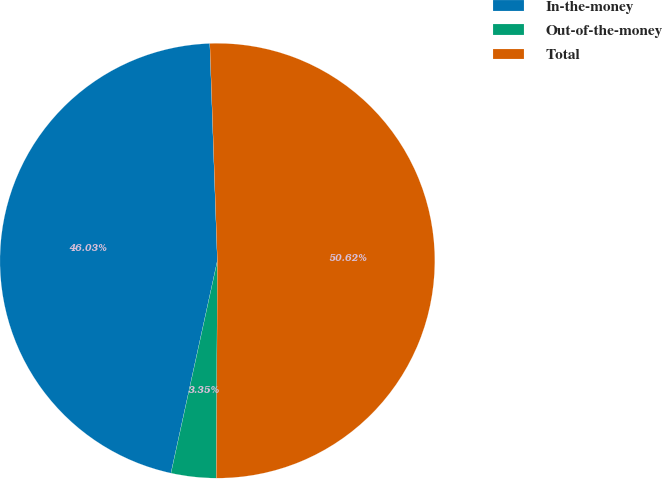<chart> <loc_0><loc_0><loc_500><loc_500><pie_chart><fcel>In-the-money<fcel>Out-of-the-money<fcel>Total<nl><fcel>46.03%<fcel>3.35%<fcel>50.63%<nl></chart> 